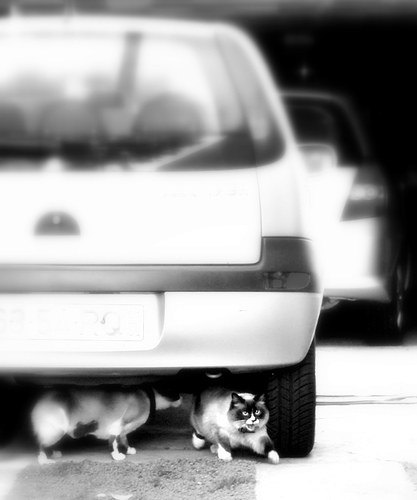What do the cats appear to be doing under the car? The cats seem to be seeking shade or possibly hiding under the car, which is common feline behavior when seeking a safe or cool resting spot. 